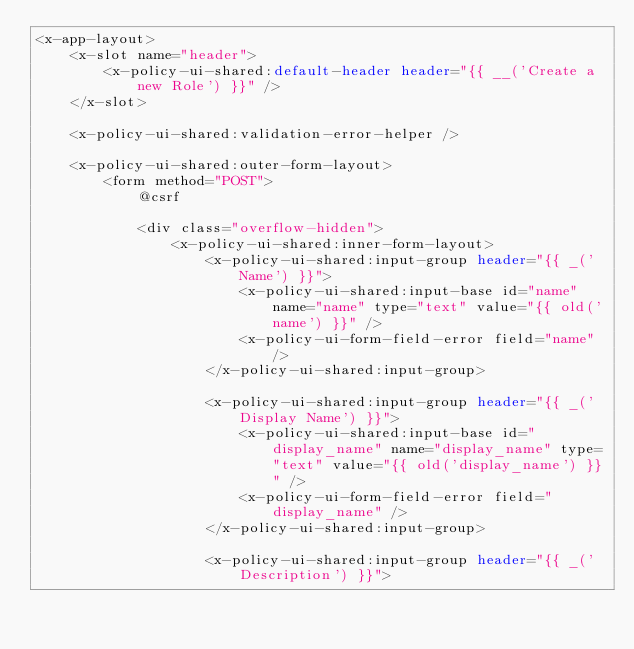Convert code to text. <code><loc_0><loc_0><loc_500><loc_500><_PHP_><x-app-layout>
    <x-slot name="header">
        <x-policy-ui-shared:default-header header="{{ __('Create a new Role') }}" />
    </x-slot>

    <x-policy-ui-shared:validation-error-helper />

    <x-policy-ui-shared:outer-form-layout>
        <form method="POST">
            @csrf

            <div class="overflow-hidden">
                <x-policy-ui-shared:inner-form-layout>
                    <x-policy-ui-shared:input-group header="{{ _('Name') }}">
                        <x-policy-ui-shared:input-base id="name" name="name" type="text" value="{{ old('name') }}" />
                        <x-policy-ui-form-field-error field="name" />
                    </x-policy-ui-shared:input-group>

                    <x-policy-ui-shared:input-group header="{{ _('Display Name') }}">
                        <x-policy-ui-shared:input-base id="display_name" name="display_name" type="text" value="{{ old('display_name') }}" />
                        <x-policy-ui-form-field-error field="display_name" />
                    </x-policy-ui-shared:input-group>

                    <x-policy-ui-shared:input-group header="{{ _('Description') }}"></code> 